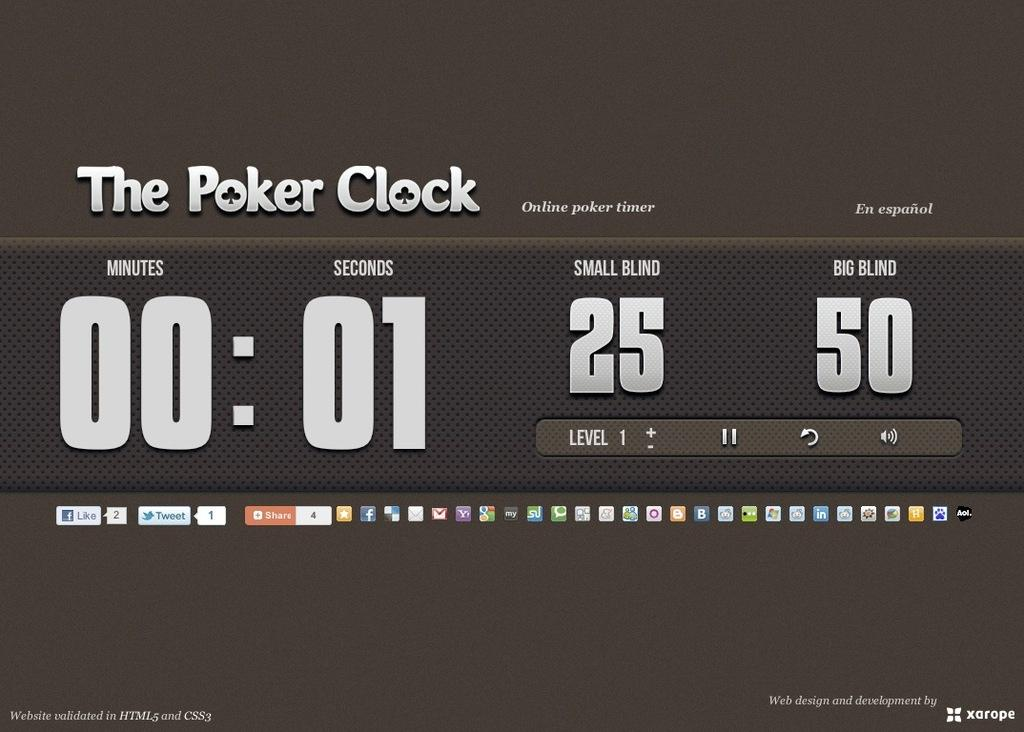Provide a one-sentence caption for the provided image. A screen showing a web page called The Poker Clock shows an online poker timer. 